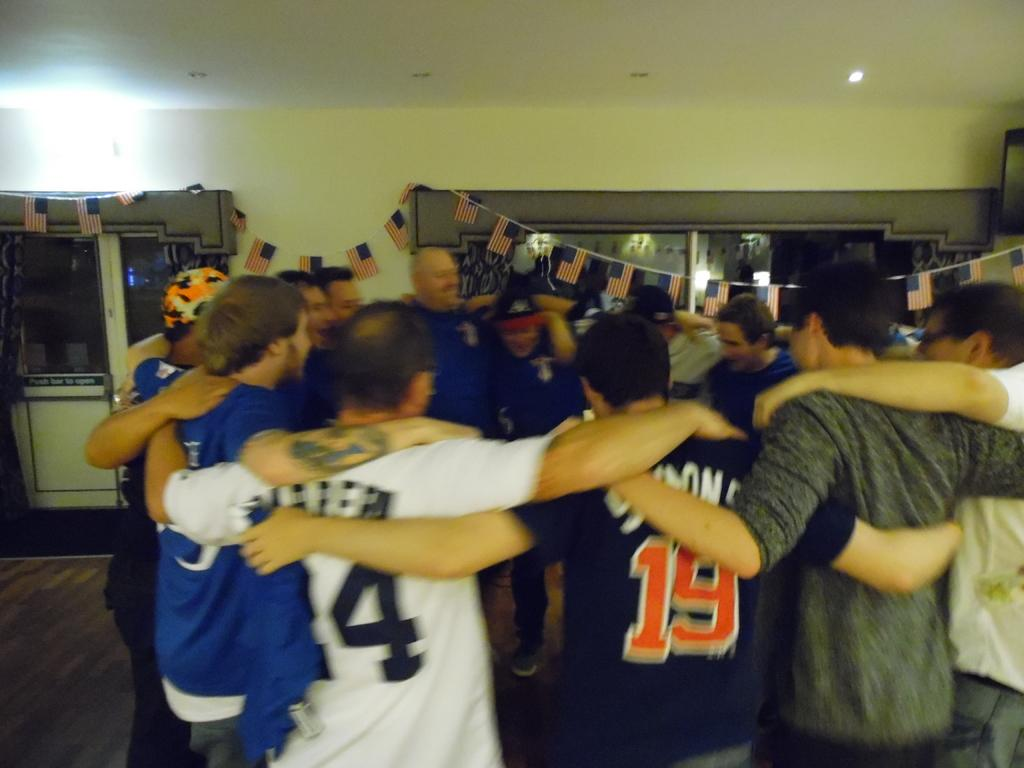<image>
Render a clear and concise summary of the photo. some men in sports jerseys like 19 all hugging in a room 